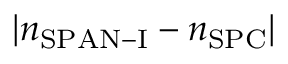<formula> <loc_0><loc_0><loc_500><loc_500>| n _ { S P A N - I } - n _ { S P C } |</formula> 